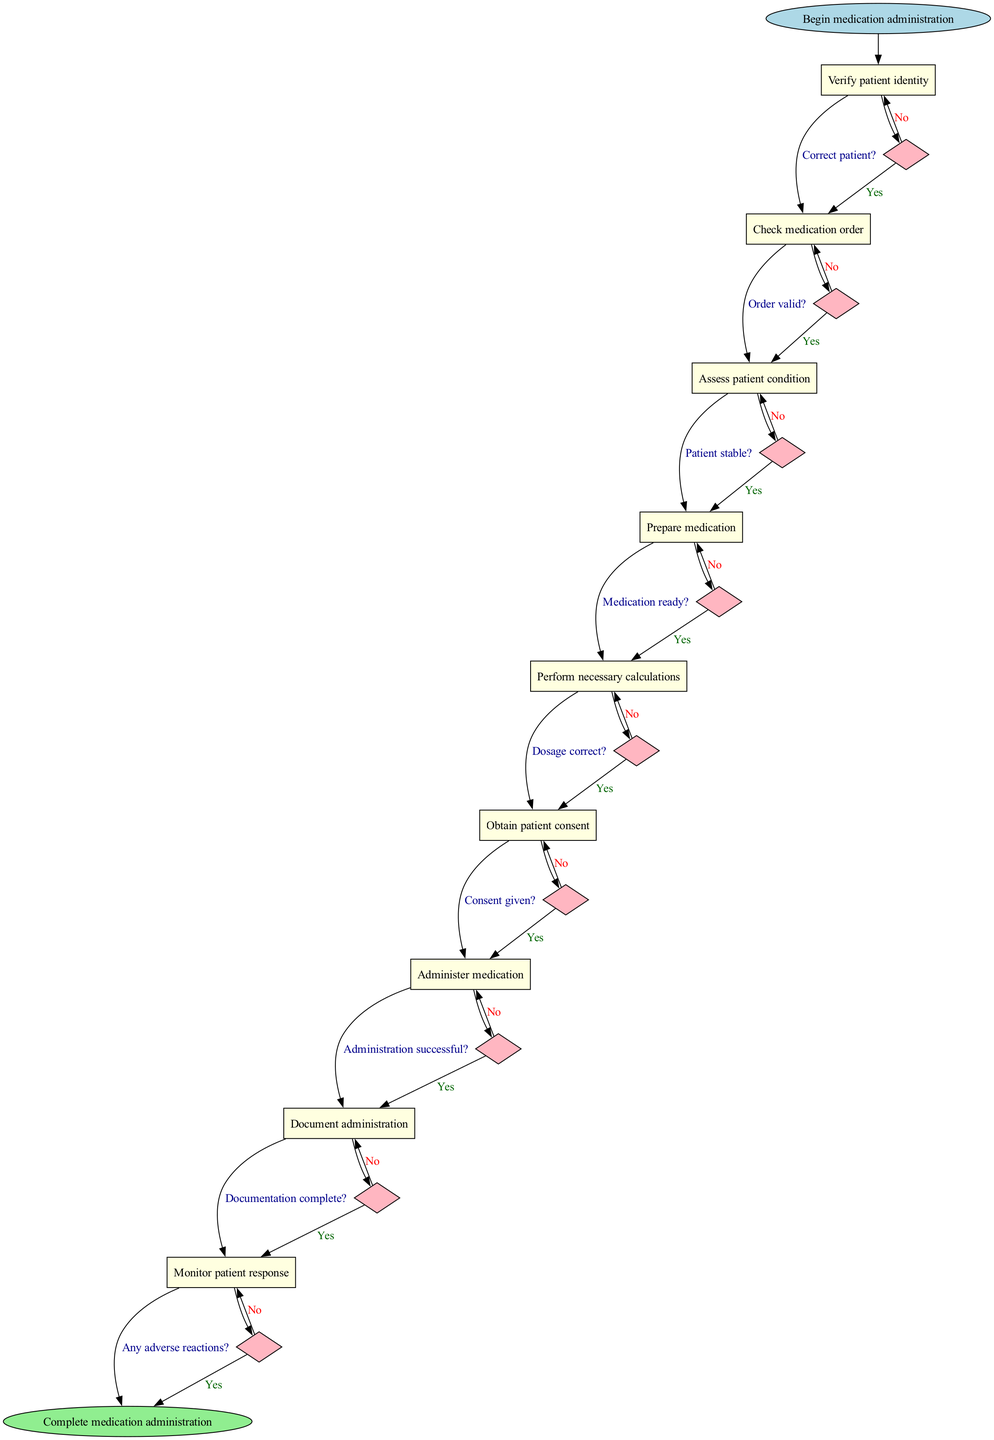What is the first step in the medication administration workflow? The first step in the workflow is indicated as "Begin medication administration," which is the starting point in the flowchart.
Answer: Begin medication administration How many nodes are present in the workflow diagram? The flowchart contains a total of 10 nodes: 1 start node, 8 process nodes, and 1 end node. Counting all of these together gives a total of 10.
Answer: 10 Which node follows the "Verify patient identity" node? According to the flow of the diagram, the node that follows "Verify patient identity" is "Check medication order." This can be seen from the linking edges that connect these two nodes.
Answer: Check medication order What is the final step of the medication administration workflow? The last step in the workflow, indicated by the end node, is "Complete medication administration." This signifies the end of the medication process.
Answer: Complete medication administration What decision must be made after "Perform necessary calculations"? After "Perform necessary calculations," the decision labeled with "Dosage correct?" needs to be made, determining if the calculated dosage is accurate before proceeding.
Answer: Dosage correct? Identify the node that comes after the decision "Consent given?" The workflow indicates that after the decision "Consent given?" if the answer is yes, the next node would be "Administer medication," which follows the approval of consent from the patient.
Answer: Administer medication How many decision points are included in the diagram? The diagram includes 8 decision points, represented in the flowchart by the edges with a question mark, indicating a decision needs to be made at each of those points.
Answer: 8 What happens if the administration is not successful according to the flowchart? If "Administration successful?" node has a response of "No," the flowchart loops back to the "Administer medication" node, indicating that the administration must be attempted again.
Answer: Loop back to Administer medication Which node is reached after monitoring for adverse reactions? After monitoring for any adverse reactions, if no reactions are detected (implying successful administration), the flowchart leads directly to the "Complete medication administration" node.
Answer: Complete medication administration 